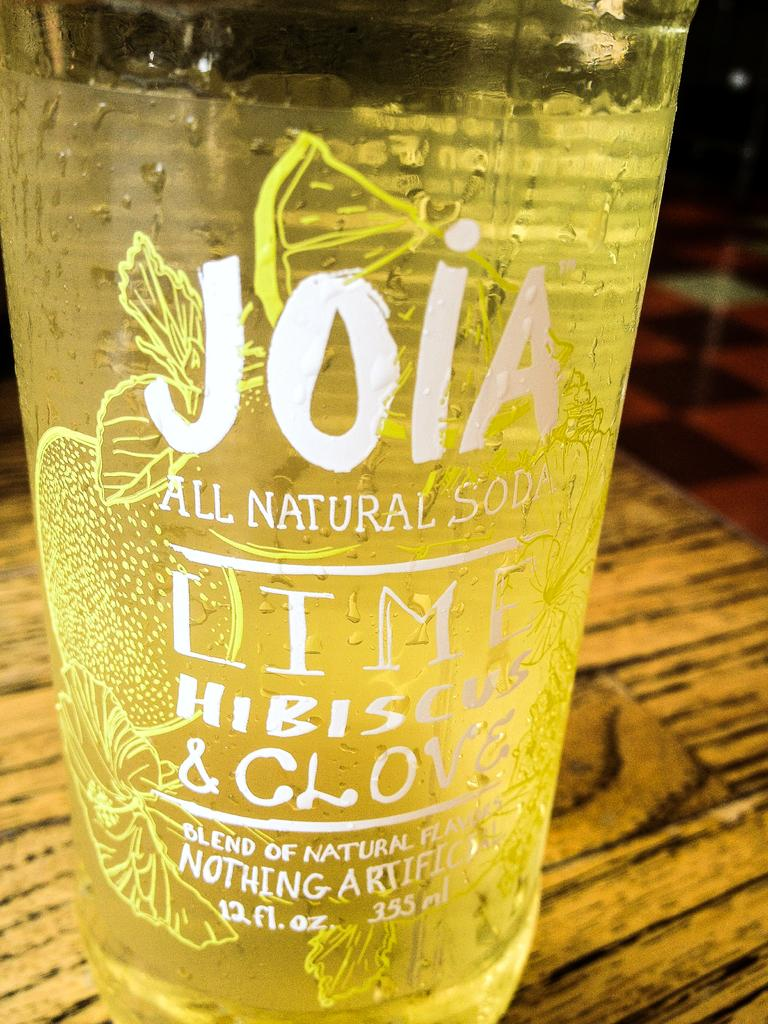<image>
Give a short and clear explanation of the subsequent image. A glass with the writing Joia all natural soda lime hibiscus and clove on it 